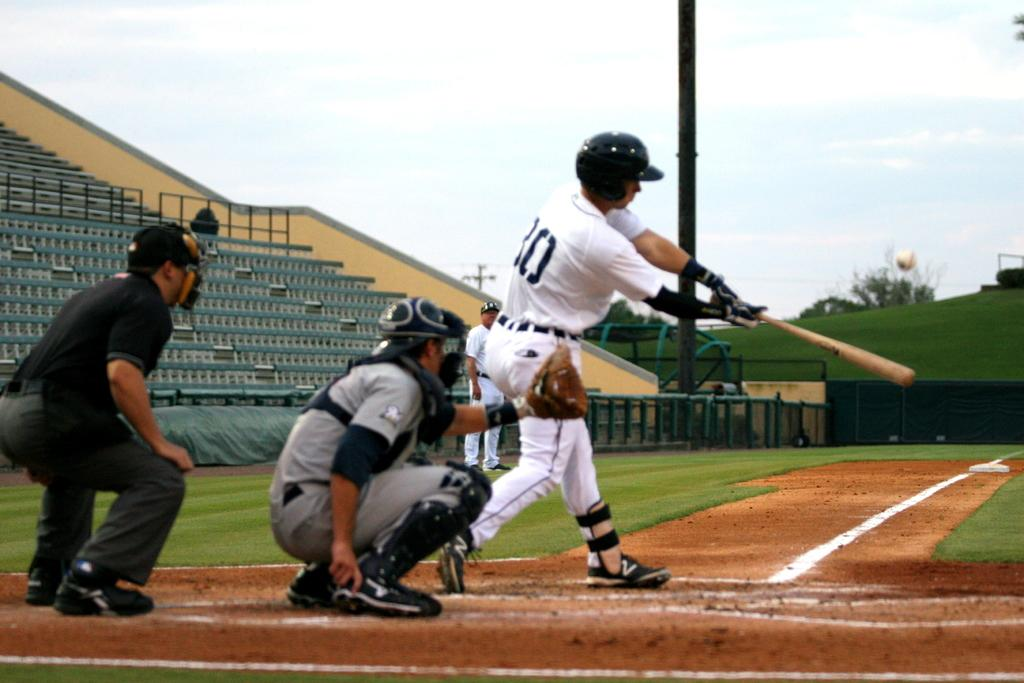<image>
Give a short and clear explanation of the subsequent image. baseball player in white wearing number 30 or maybe 80 swings the bat at the ball 